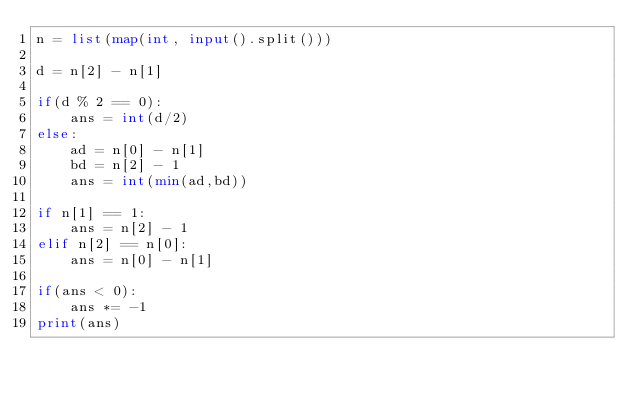Convert code to text. <code><loc_0><loc_0><loc_500><loc_500><_Python_>n = list(map(int, input().split()))

d = n[2] - n[1]

if(d % 2 == 0):
    ans = int(d/2)
else:
    ad = n[0] - n[1]
    bd = n[2] - 1
    ans = int(min(ad,bd))

if n[1] == 1:
    ans = n[2] - 1
elif n[2] == n[0]:
    ans = n[0] - n[1]

if(ans < 0):
    ans *= -1
print(ans)</code> 